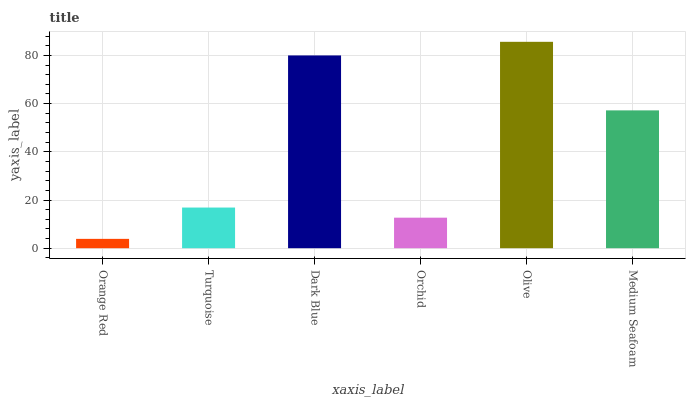Is Orange Red the minimum?
Answer yes or no. Yes. Is Olive the maximum?
Answer yes or no. Yes. Is Turquoise the minimum?
Answer yes or no. No. Is Turquoise the maximum?
Answer yes or no. No. Is Turquoise greater than Orange Red?
Answer yes or no. Yes. Is Orange Red less than Turquoise?
Answer yes or no. Yes. Is Orange Red greater than Turquoise?
Answer yes or no. No. Is Turquoise less than Orange Red?
Answer yes or no. No. Is Medium Seafoam the high median?
Answer yes or no. Yes. Is Turquoise the low median?
Answer yes or no. Yes. Is Dark Blue the high median?
Answer yes or no. No. Is Medium Seafoam the low median?
Answer yes or no. No. 